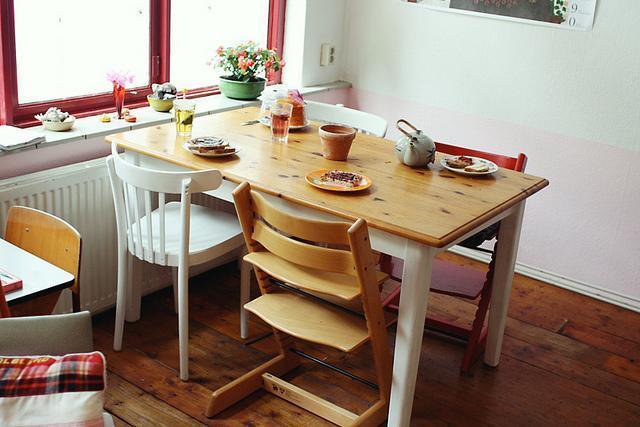How many chairs match the table top?
Give a very brief answer. 1. How many chairs are there?
Give a very brief answer. 4. 